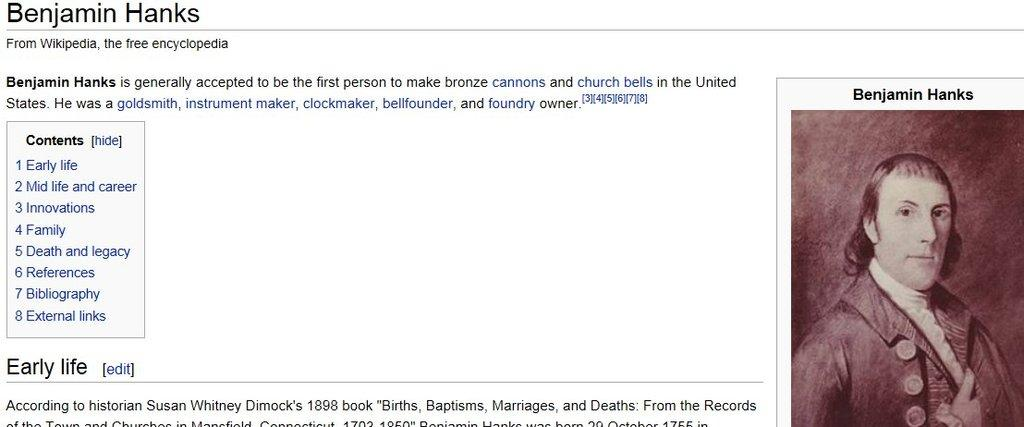What is the source of the image? The image is a screenshot from Wikipedia. What can be found on the right hand side of the image? There is text and a picture of a person on the right hand side of the image. What is the size of the baseball in the image? There is no baseball present in the image. How many eyes does the person in the image have? The image only shows a picture of a person, and we cannot determine the number of eyes from the image alone. 